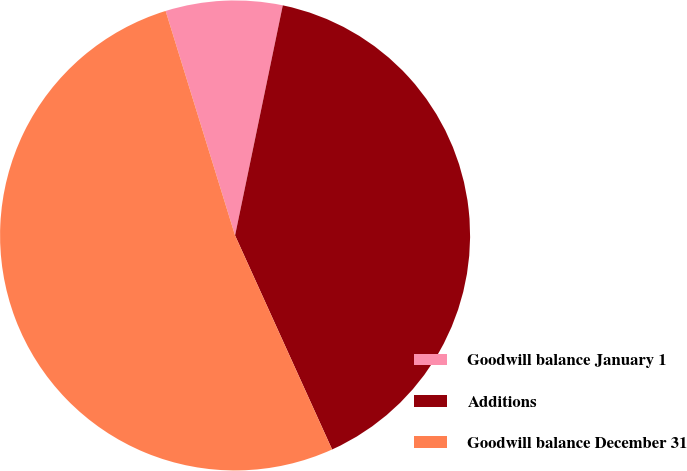Convert chart to OTSL. <chart><loc_0><loc_0><loc_500><loc_500><pie_chart><fcel>Goodwill balance January 1<fcel>Additions<fcel>Goodwill balance December 31<nl><fcel>8.03%<fcel>39.97%<fcel>52.0%<nl></chart> 